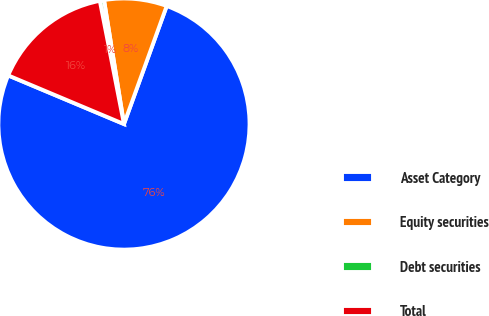Convert chart. <chart><loc_0><loc_0><loc_500><loc_500><pie_chart><fcel>Asset Category<fcel>Equity securities<fcel>Debt securities<fcel>Total<nl><fcel>75.8%<fcel>8.07%<fcel>0.54%<fcel>15.59%<nl></chart> 